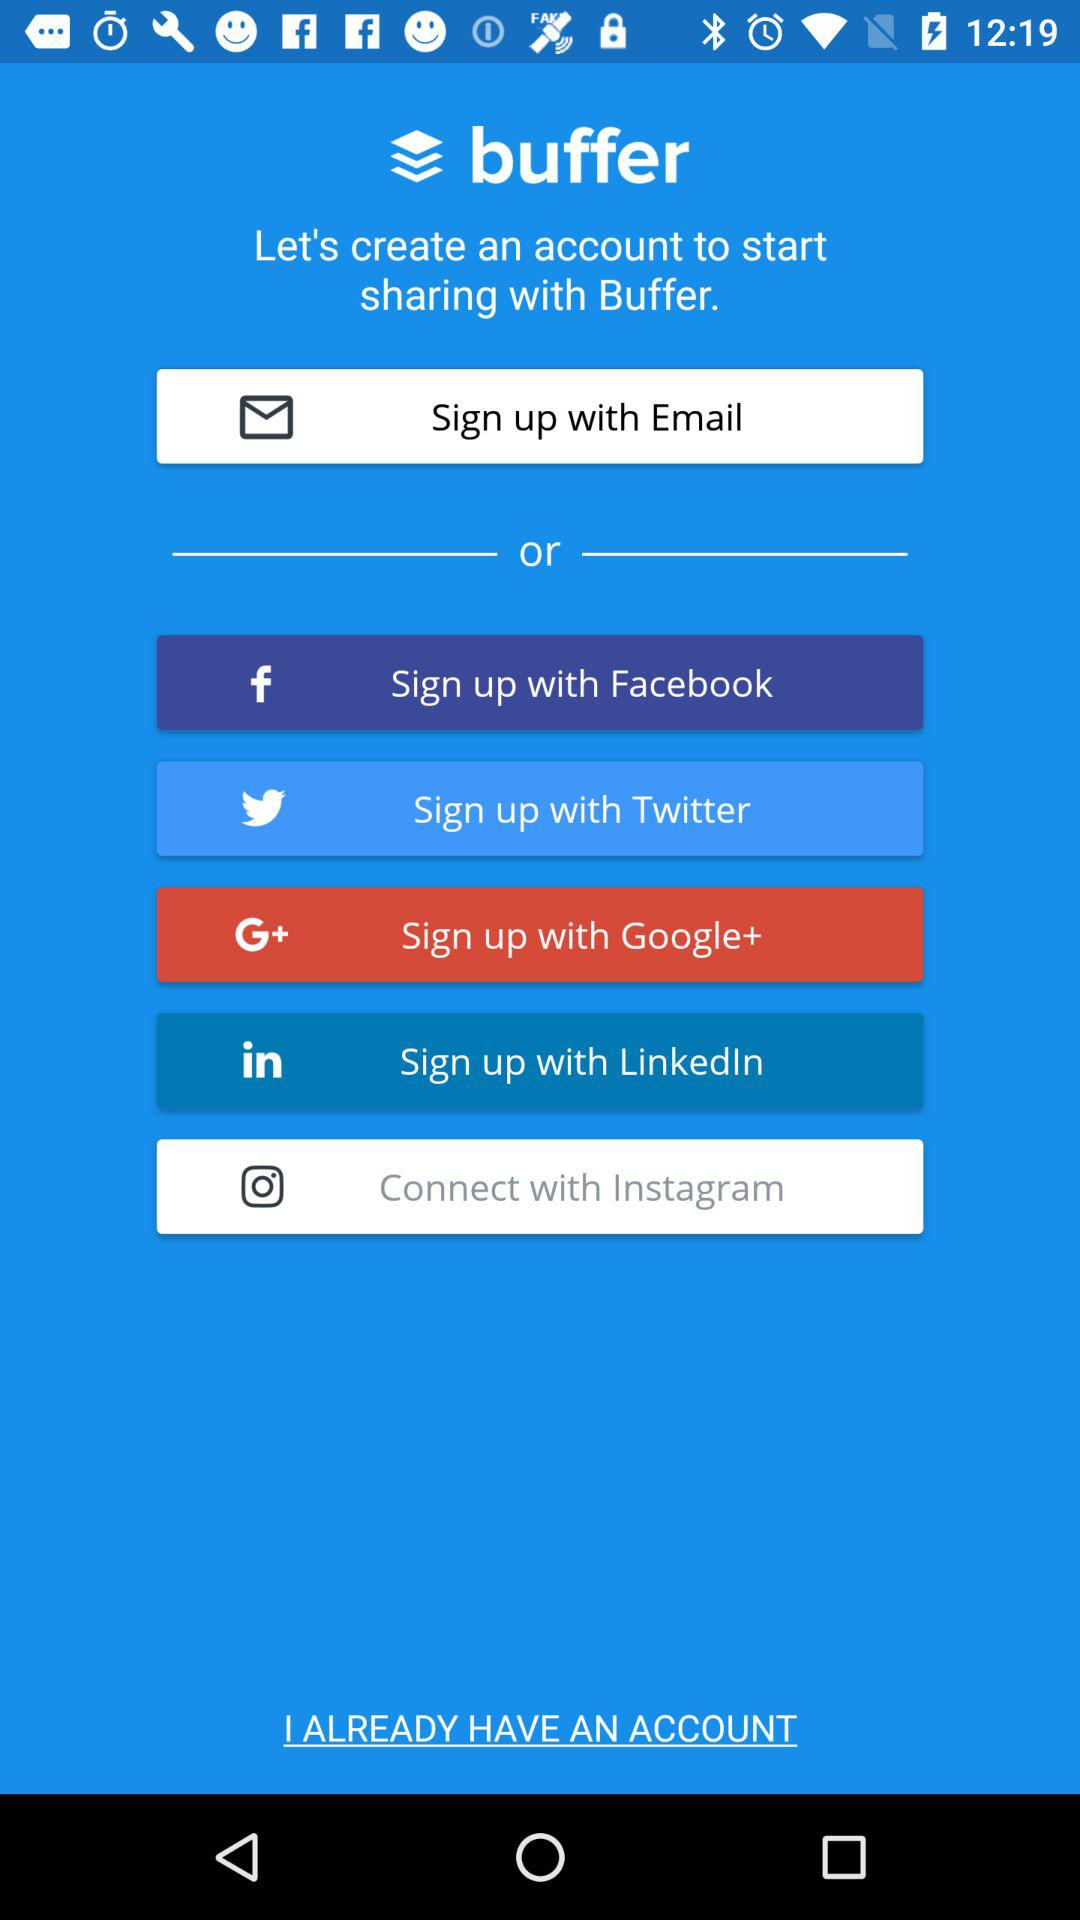What are the different sign up options? The different sign up options are "Email", "Facebook", "Twitter", "Google+" and "LinkedIn". 